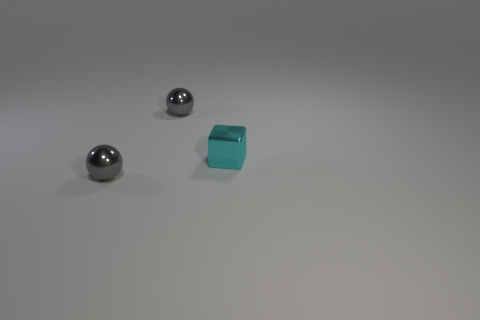What might be the purpose of these objects? While their specific purpose isn't clear without additional context, they could potentially be used for educational demonstrations about geometry and physics, or as decorative objects given their simple yet elegant forms. Could these objects have any practical use? Certainly! The spherical shapes could function as ball bearings, and if the block is sturdy, it might serve as a paperweight or part of a building set for children. 